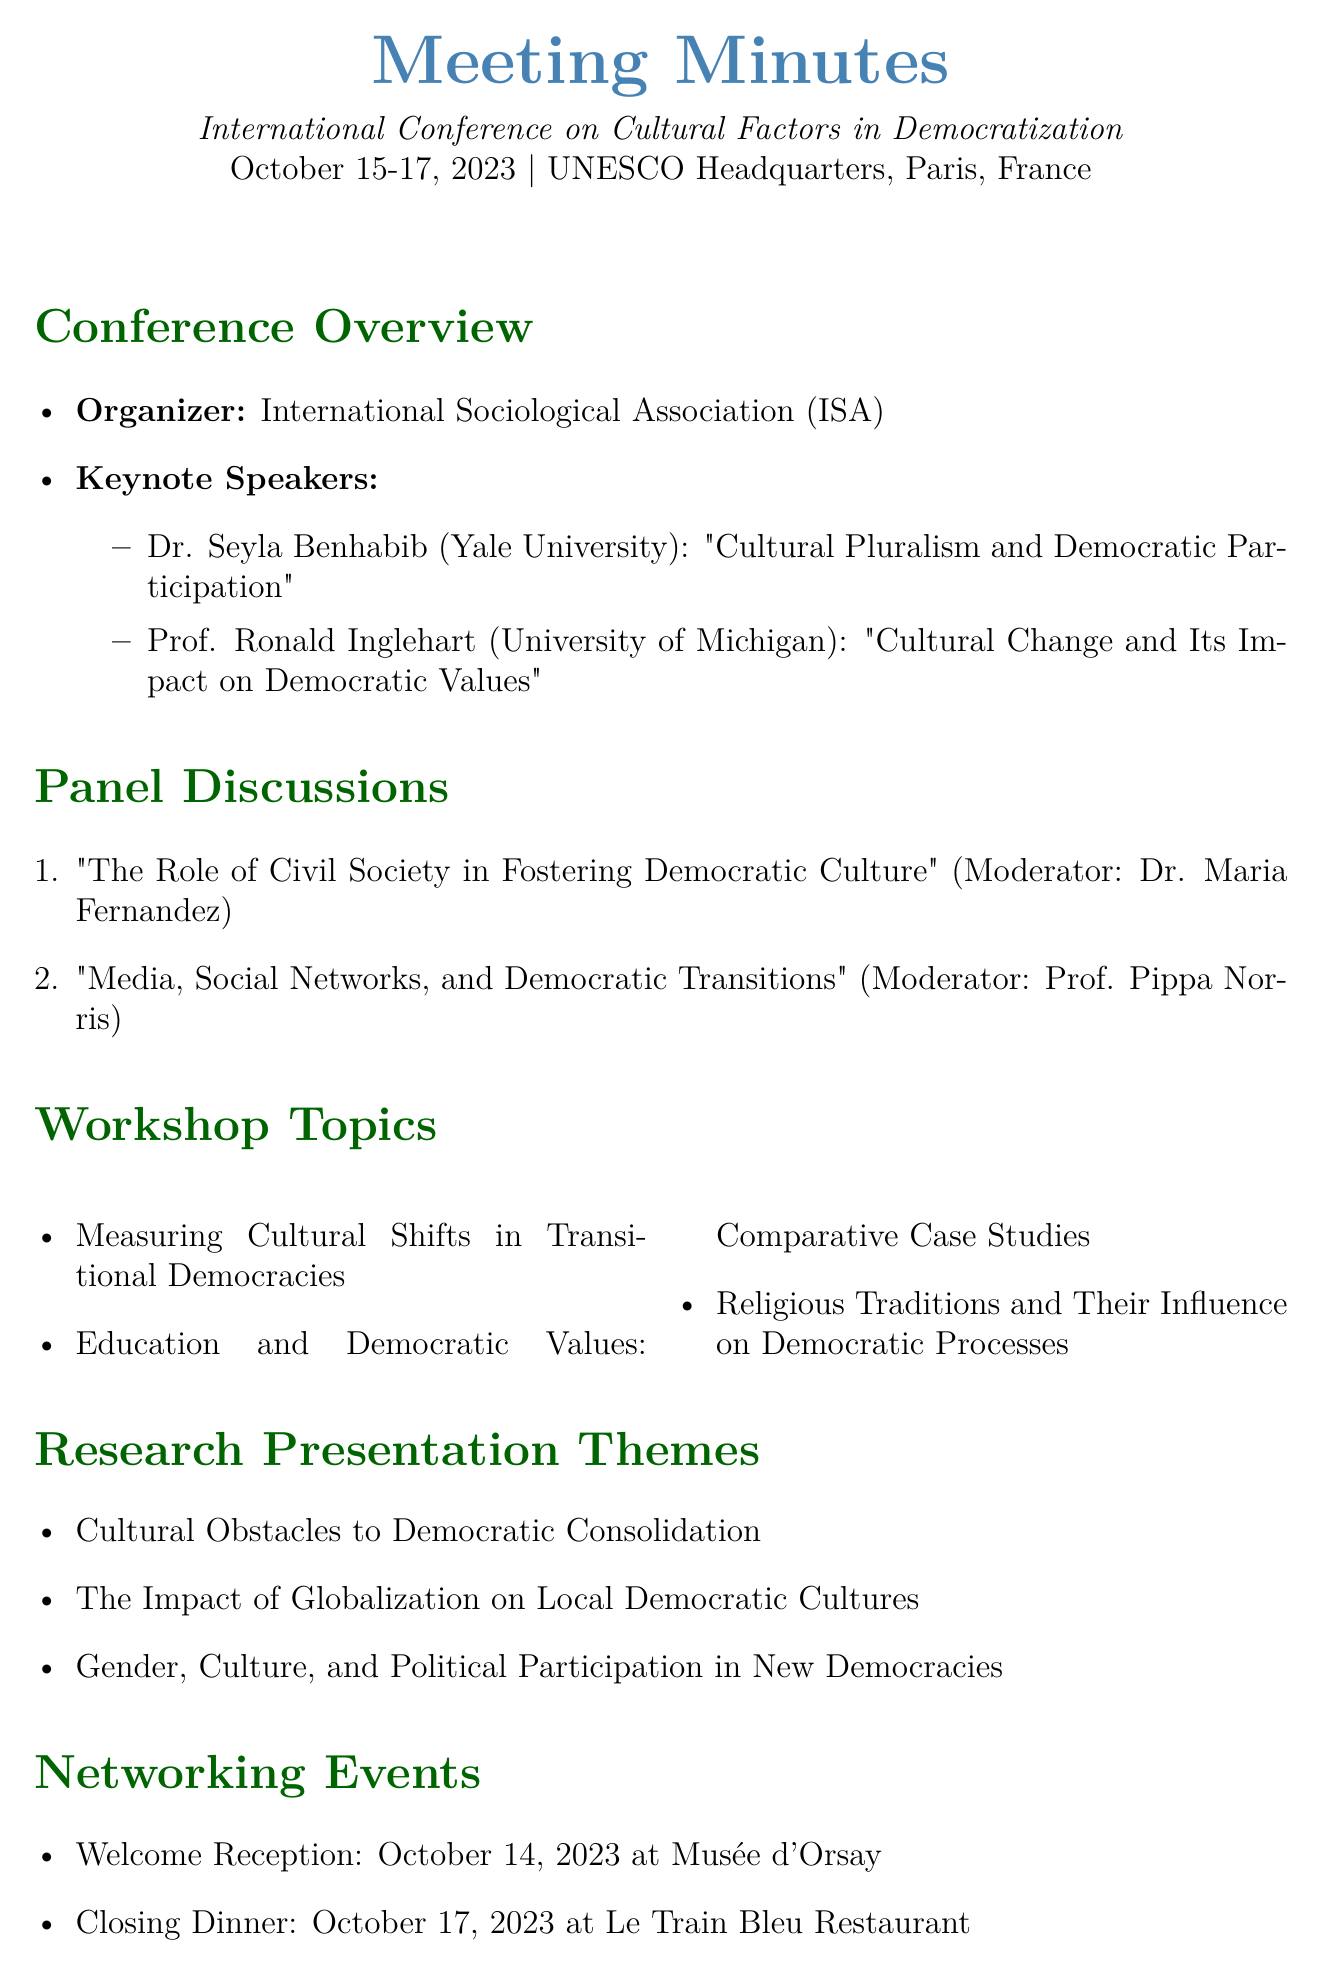What are the dates of the conference? The document states that the conference will take place from October 15-17, 2023.
Answer: October 15-17, 2023 Who is the organizer of the conference? The meeting minutes specify that the organizer is the International Sociological Association (ISA).
Answer: International Sociological Association (ISA) What is the topic of Dr. Seyla Benhabib's keynote address? The document lists Dr. Seyla Benhabib as speaking on "Cultural Pluralism and Democratic Participation."
Answer: Cultural Pluralism and Democratic Participation Which venue will host the Welcome Reception? The meeting minutes indicate that the Welcome Reception will be held at the Musée d'Orsay.
Answer: Musée d'Orsay What is the submission deadline for the special issue? The document mentions that the submission deadline for the special issue is December 31, 2023.
Answer: December 31, 2023 How many workshop topics are listed in the document? The document includes a total of three workshop topics under the Workshop Topics section.
Answer: Three Who moderates the panel discussion on media and social networks? The document notes that Prof. Pippa Norris will moderate the discussion on "Media, Social Networks, and Democratic Transitions."
Answer: Prof. Pippa Norris What type of publication opportunity is mentioned? The meeting minutes refer to a special issue in the journal Democratization.
Answer: Journal Democratization What thematic area is highlighted in the research presentation related to gender? The document states "Gender, Culture, and Political Participation in New Democracies" as a research presentation theme.
Answer: Gender, Culture, and Political Participation in New Democracies 